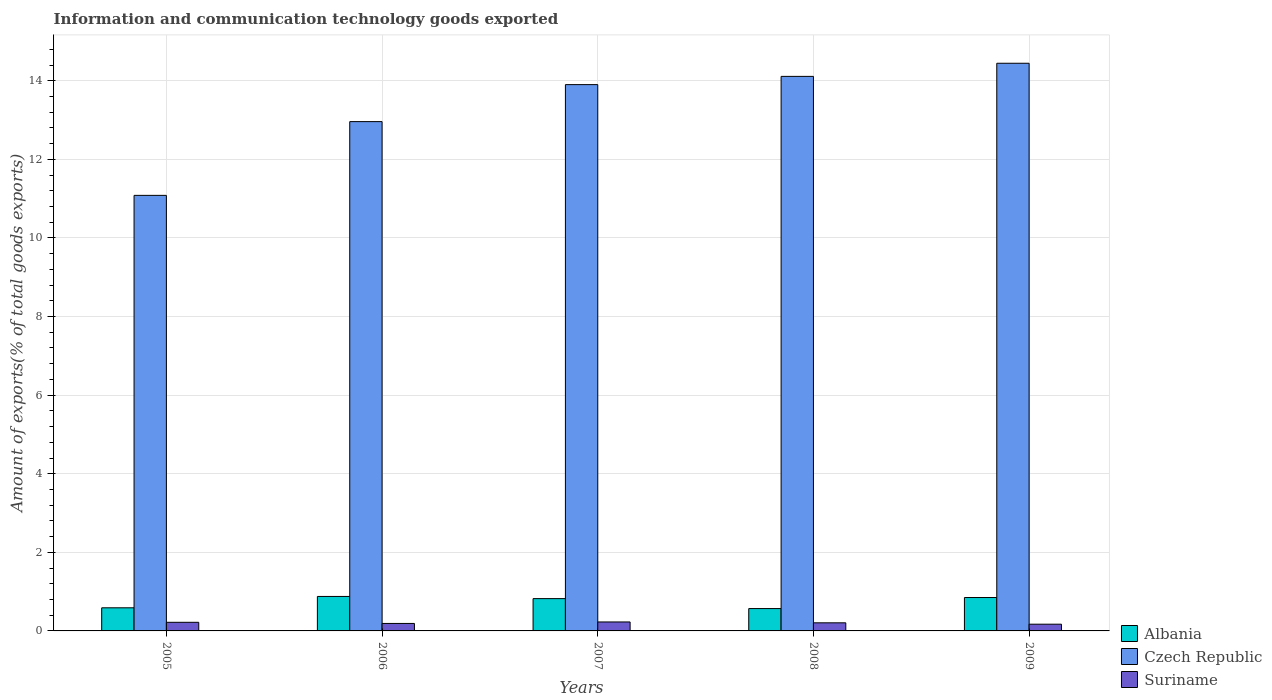How many groups of bars are there?
Your response must be concise. 5. Are the number of bars per tick equal to the number of legend labels?
Give a very brief answer. Yes. How many bars are there on the 5th tick from the left?
Give a very brief answer. 3. In how many cases, is the number of bars for a given year not equal to the number of legend labels?
Your response must be concise. 0. What is the amount of goods exported in Czech Republic in 2006?
Give a very brief answer. 12.96. Across all years, what is the maximum amount of goods exported in Albania?
Offer a very short reply. 0.88. Across all years, what is the minimum amount of goods exported in Albania?
Offer a very short reply. 0.57. In which year was the amount of goods exported in Suriname maximum?
Offer a terse response. 2007. In which year was the amount of goods exported in Czech Republic minimum?
Offer a terse response. 2005. What is the total amount of goods exported in Suriname in the graph?
Ensure brevity in your answer.  1.01. What is the difference between the amount of goods exported in Suriname in 2006 and that in 2008?
Keep it short and to the point. -0.02. What is the difference between the amount of goods exported in Suriname in 2009 and the amount of goods exported in Czech Republic in 2006?
Your answer should be very brief. -12.79. What is the average amount of goods exported in Albania per year?
Your answer should be very brief. 0.74. In the year 2007, what is the difference between the amount of goods exported in Albania and amount of goods exported in Suriname?
Offer a very short reply. 0.59. In how many years, is the amount of goods exported in Albania greater than 12.8 %?
Your answer should be very brief. 0. What is the ratio of the amount of goods exported in Suriname in 2007 to that in 2009?
Give a very brief answer. 1.33. What is the difference between the highest and the second highest amount of goods exported in Czech Republic?
Offer a terse response. 0.33. What is the difference between the highest and the lowest amount of goods exported in Albania?
Offer a terse response. 0.31. In how many years, is the amount of goods exported in Czech Republic greater than the average amount of goods exported in Czech Republic taken over all years?
Your answer should be compact. 3. Is the sum of the amount of goods exported in Czech Republic in 2006 and 2009 greater than the maximum amount of goods exported in Albania across all years?
Ensure brevity in your answer.  Yes. What does the 2nd bar from the left in 2007 represents?
Your response must be concise. Czech Republic. What does the 1st bar from the right in 2006 represents?
Make the answer very short. Suriname. Are all the bars in the graph horizontal?
Your answer should be compact. No. Does the graph contain any zero values?
Provide a succinct answer. No. Does the graph contain grids?
Your answer should be compact. Yes. Where does the legend appear in the graph?
Offer a terse response. Bottom right. How many legend labels are there?
Ensure brevity in your answer.  3. What is the title of the graph?
Provide a succinct answer. Information and communication technology goods exported. Does "Chad" appear as one of the legend labels in the graph?
Your response must be concise. No. What is the label or title of the X-axis?
Offer a very short reply. Years. What is the label or title of the Y-axis?
Provide a short and direct response. Amount of exports(% of total goods exports). What is the Amount of exports(% of total goods exports) of Albania in 2005?
Your answer should be very brief. 0.59. What is the Amount of exports(% of total goods exports) of Czech Republic in 2005?
Your response must be concise. 11.08. What is the Amount of exports(% of total goods exports) of Suriname in 2005?
Your answer should be compact. 0.22. What is the Amount of exports(% of total goods exports) of Albania in 2006?
Your answer should be very brief. 0.88. What is the Amount of exports(% of total goods exports) of Czech Republic in 2006?
Your answer should be compact. 12.96. What is the Amount of exports(% of total goods exports) of Suriname in 2006?
Provide a short and direct response. 0.19. What is the Amount of exports(% of total goods exports) in Albania in 2007?
Your response must be concise. 0.82. What is the Amount of exports(% of total goods exports) of Czech Republic in 2007?
Your answer should be compact. 13.9. What is the Amount of exports(% of total goods exports) in Suriname in 2007?
Provide a succinct answer. 0.23. What is the Amount of exports(% of total goods exports) in Albania in 2008?
Your answer should be very brief. 0.57. What is the Amount of exports(% of total goods exports) in Czech Republic in 2008?
Provide a succinct answer. 14.11. What is the Amount of exports(% of total goods exports) in Suriname in 2008?
Make the answer very short. 0.21. What is the Amount of exports(% of total goods exports) in Albania in 2009?
Your response must be concise. 0.85. What is the Amount of exports(% of total goods exports) in Czech Republic in 2009?
Your answer should be very brief. 14.44. What is the Amount of exports(% of total goods exports) of Suriname in 2009?
Offer a very short reply. 0.17. Across all years, what is the maximum Amount of exports(% of total goods exports) in Albania?
Your response must be concise. 0.88. Across all years, what is the maximum Amount of exports(% of total goods exports) in Czech Republic?
Your response must be concise. 14.44. Across all years, what is the maximum Amount of exports(% of total goods exports) of Suriname?
Give a very brief answer. 0.23. Across all years, what is the minimum Amount of exports(% of total goods exports) in Albania?
Provide a succinct answer. 0.57. Across all years, what is the minimum Amount of exports(% of total goods exports) of Czech Republic?
Offer a terse response. 11.08. Across all years, what is the minimum Amount of exports(% of total goods exports) in Suriname?
Provide a succinct answer. 0.17. What is the total Amount of exports(% of total goods exports) in Albania in the graph?
Your answer should be very brief. 3.71. What is the total Amount of exports(% of total goods exports) of Czech Republic in the graph?
Offer a very short reply. 66.5. What is the total Amount of exports(% of total goods exports) of Suriname in the graph?
Give a very brief answer. 1.01. What is the difference between the Amount of exports(% of total goods exports) in Albania in 2005 and that in 2006?
Your answer should be very brief. -0.29. What is the difference between the Amount of exports(% of total goods exports) in Czech Republic in 2005 and that in 2006?
Provide a short and direct response. -1.88. What is the difference between the Amount of exports(% of total goods exports) in Suriname in 2005 and that in 2006?
Your response must be concise. 0.03. What is the difference between the Amount of exports(% of total goods exports) of Albania in 2005 and that in 2007?
Your answer should be compact. -0.23. What is the difference between the Amount of exports(% of total goods exports) in Czech Republic in 2005 and that in 2007?
Keep it short and to the point. -2.82. What is the difference between the Amount of exports(% of total goods exports) of Suriname in 2005 and that in 2007?
Offer a very short reply. -0.01. What is the difference between the Amount of exports(% of total goods exports) of Albania in 2005 and that in 2008?
Provide a short and direct response. 0.02. What is the difference between the Amount of exports(% of total goods exports) of Czech Republic in 2005 and that in 2008?
Make the answer very short. -3.03. What is the difference between the Amount of exports(% of total goods exports) of Suriname in 2005 and that in 2008?
Provide a succinct answer. 0.01. What is the difference between the Amount of exports(% of total goods exports) of Albania in 2005 and that in 2009?
Ensure brevity in your answer.  -0.26. What is the difference between the Amount of exports(% of total goods exports) in Czech Republic in 2005 and that in 2009?
Your answer should be compact. -3.36. What is the difference between the Amount of exports(% of total goods exports) in Suriname in 2005 and that in 2009?
Offer a terse response. 0.05. What is the difference between the Amount of exports(% of total goods exports) in Albania in 2006 and that in 2007?
Provide a short and direct response. 0.06. What is the difference between the Amount of exports(% of total goods exports) of Czech Republic in 2006 and that in 2007?
Your answer should be very brief. -0.94. What is the difference between the Amount of exports(% of total goods exports) in Suriname in 2006 and that in 2007?
Ensure brevity in your answer.  -0.04. What is the difference between the Amount of exports(% of total goods exports) in Albania in 2006 and that in 2008?
Your answer should be very brief. 0.31. What is the difference between the Amount of exports(% of total goods exports) of Czech Republic in 2006 and that in 2008?
Make the answer very short. -1.15. What is the difference between the Amount of exports(% of total goods exports) of Suriname in 2006 and that in 2008?
Keep it short and to the point. -0.02. What is the difference between the Amount of exports(% of total goods exports) of Albania in 2006 and that in 2009?
Provide a succinct answer. 0.03. What is the difference between the Amount of exports(% of total goods exports) of Czech Republic in 2006 and that in 2009?
Your answer should be very brief. -1.48. What is the difference between the Amount of exports(% of total goods exports) in Suriname in 2006 and that in 2009?
Provide a succinct answer. 0.02. What is the difference between the Amount of exports(% of total goods exports) in Albania in 2007 and that in 2008?
Provide a succinct answer. 0.25. What is the difference between the Amount of exports(% of total goods exports) in Czech Republic in 2007 and that in 2008?
Provide a succinct answer. -0.21. What is the difference between the Amount of exports(% of total goods exports) of Suriname in 2007 and that in 2008?
Keep it short and to the point. 0.02. What is the difference between the Amount of exports(% of total goods exports) of Albania in 2007 and that in 2009?
Your answer should be compact. -0.03. What is the difference between the Amount of exports(% of total goods exports) of Czech Republic in 2007 and that in 2009?
Provide a succinct answer. -0.54. What is the difference between the Amount of exports(% of total goods exports) in Suriname in 2007 and that in 2009?
Make the answer very short. 0.06. What is the difference between the Amount of exports(% of total goods exports) in Albania in 2008 and that in 2009?
Keep it short and to the point. -0.28. What is the difference between the Amount of exports(% of total goods exports) of Czech Republic in 2008 and that in 2009?
Your response must be concise. -0.33. What is the difference between the Amount of exports(% of total goods exports) of Suriname in 2008 and that in 2009?
Provide a succinct answer. 0.04. What is the difference between the Amount of exports(% of total goods exports) in Albania in 2005 and the Amount of exports(% of total goods exports) in Czech Republic in 2006?
Your answer should be compact. -12.37. What is the difference between the Amount of exports(% of total goods exports) in Albania in 2005 and the Amount of exports(% of total goods exports) in Suriname in 2006?
Make the answer very short. 0.4. What is the difference between the Amount of exports(% of total goods exports) of Czech Republic in 2005 and the Amount of exports(% of total goods exports) of Suriname in 2006?
Your response must be concise. 10.89. What is the difference between the Amount of exports(% of total goods exports) of Albania in 2005 and the Amount of exports(% of total goods exports) of Czech Republic in 2007?
Provide a short and direct response. -13.31. What is the difference between the Amount of exports(% of total goods exports) in Albania in 2005 and the Amount of exports(% of total goods exports) in Suriname in 2007?
Give a very brief answer. 0.36. What is the difference between the Amount of exports(% of total goods exports) of Czech Republic in 2005 and the Amount of exports(% of total goods exports) of Suriname in 2007?
Provide a succinct answer. 10.85. What is the difference between the Amount of exports(% of total goods exports) of Albania in 2005 and the Amount of exports(% of total goods exports) of Czech Republic in 2008?
Your response must be concise. -13.52. What is the difference between the Amount of exports(% of total goods exports) of Albania in 2005 and the Amount of exports(% of total goods exports) of Suriname in 2008?
Keep it short and to the point. 0.38. What is the difference between the Amount of exports(% of total goods exports) in Czech Republic in 2005 and the Amount of exports(% of total goods exports) in Suriname in 2008?
Offer a terse response. 10.88. What is the difference between the Amount of exports(% of total goods exports) of Albania in 2005 and the Amount of exports(% of total goods exports) of Czech Republic in 2009?
Keep it short and to the point. -13.86. What is the difference between the Amount of exports(% of total goods exports) in Albania in 2005 and the Amount of exports(% of total goods exports) in Suriname in 2009?
Offer a terse response. 0.42. What is the difference between the Amount of exports(% of total goods exports) of Czech Republic in 2005 and the Amount of exports(% of total goods exports) of Suriname in 2009?
Offer a terse response. 10.91. What is the difference between the Amount of exports(% of total goods exports) of Albania in 2006 and the Amount of exports(% of total goods exports) of Czech Republic in 2007?
Your answer should be compact. -13.02. What is the difference between the Amount of exports(% of total goods exports) in Albania in 2006 and the Amount of exports(% of total goods exports) in Suriname in 2007?
Provide a succinct answer. 0.65. What is the difference between the Amount of exports(% of total goods exports) of Czech Republic in 2006 and the Amount of exports(% of total goods exports) of Suriname in 2007?
Offer a very short reply. 12.73. What is the difference between the Amount of exports(% of total goods exports) of Albania in 2006 and the Amount of exports(% of total goods exports) of Czech Republic in 2008?
Your answer should be very brief. -13.23. What is the difference between the Amount of exports(% of total goods exports) of Albania in 2006 and the Amount of exports(% of total goods exports) of Suriname in 2008?
Offer a terse response. 0.67. What is the difference between the Amount of exports(% of total goods exports) in Czech Republic in 2006 and the Amount of exports(% of total goods exports) in Suriname in 2008?
Provide a short and direct response. 12.75. What is the difference between the Amount of exports(% of total goods exports) of Albania in 2006 and the Amount of exports(% of total goods exports) of Czech Republic in 2009?
Offer a very short reply. -13.57. What is the difference between the Amount of exports(% of total goods exports) of Albania in 2006 and the Amount of exports(% of total goods exports) of Suriname in 2009?
Provide a succinct answer. 0.71. What is the difference between the Amount of exports(% of total goods exports) in Czech Republic in 2006 and the Amount of exports(% of total goods exports) in Suriname in 2009?
Provide a succinct answer. 12.79. What is the difference between the Amount of exports(% of total goods exports) in Albania in 2007 and the Amount of exports(% of total goods exports) in Czech Republic in 2008?
Your answer should be very brief. -13.29. What is the difference between the Amount of exports(% of total goods exports) in Albania in 2007 and the Amount of exports(% of total goods exports) in Suriname in 2008?
Keep it short and to the point. 0.62. What is the difference between the Amount of exports(% of total goods exports) of Czech Republic in 2007 and the Amount of exports(% of total goods exports) of Suriname in 2008?
Provide a short and direct response. 13.69. What is the difference between the Amount of exports(% of total goods exports) of Albania in 2007 and the Amount of exports(% of total goods exports) of Czech Republic in 2009?
Offer a terse response. -13.62. What is the difference between the Amount of exports(% of total goods exports) of Albania in 2007 and the Amount of exports(% of total goods exports) of Suriname in 2009?
Provide a succinct answer. 0.65. What is the difference between the Amount of exports(% of total goods exports) of Czech Republic in 2007 and the Amount of exports(% of total goods exports) of Suriname in 2009?
Provide a short and direct response. 13.73. What is the difference between the Amount of exports(% of total goods exports) of Albania in 2008 and the Amount of exports(% of total goods exports) of Czech Republic in 2009?
Keep it short and to the point. -13.88. What is the difference between the Amount of exports(% of total goods exports) of Albania in 2008 and the Amount of exports(% of total goods exports) of Suriname in 2009?
Your answer should be compact. 0.4. What is the difference between the Amount of exports(% of total goods exports) of Czech Republic in 2008 and the Amount of exports(% of total goods exports) of Suriname in 2009?
Your answer should be very brief. 13.94. What is the average Amount of exports(% of total goods exports) of Albania per year?
Your answer should be very brief. 0.74. What is the average Amount of exports(% of total goods exports) in Czech Republic per year?
Provide a succinct answer. 13.3. What is the average Amount of exports(% of total goods exports) of Suriname per year?
Offer a very short reply. 0.2. In the year 2005, what is the difference between the Amount of exports(% of total goods exports) of Albania and Amount of exports(% of total goods exports) of Czech Republic?
Offer a very short reply. -10.49. In the year 2005, what is the difference between the Amount of exports(% of total goods exports) in Albania and Amount of exports(% of total goods exports) in Suriname?
Keep it short and to the point. 0.37. In the year 2005, what is the difference between the Amount of exports(% of total goods exports) of Czech Republic and Amount of exports(% of total goods exports) of Suriname?
Give a very brief answer. 10.86. In the year 2006, what is the difference between the Amount of exports(% of total goods exports) in Albania and Amount of exports(% of total goods exports) in Czech Republic?
Ensure brevity in your answer.  -12.08. In the year 2006, what is the difference between the Amount of exports(% of total goods exports) in Albania and Amount of exports(% of total goods exports) in Suriname?
Offer a very short reply. 0.69. In the year 2006, what is the difference between the Amount of exports(% of total goods exports) in Czech Republic and Amount of exports(% of total goods exports) in Suriname?
Offer a very short reply. 12.77. In the year 2007, what is the difference between the Amount of exports(% of total goods exports) in Albania and Amount of exports(% of total goods exports) in Czech Republic?
Your answer should be compact. -13.08. In the year 2007, what is the difference between the Amount of exports(% of total goods exports) in Albania and Amount of exports(% of total goods exports) in Suriname?
Offer a terse response. 0.59. In the year 2007, what is the difference between the Amount of exports(% of total goods exports) of Czech Republic and Amount of exports(% of total goods exports) of Suriname?
Provide a succinct answer. 13.67. In the year 2008, what is the difference between the Amount of exports(% of total goods exports) in Albania and Amount of exports(% of total goods exports) in Czech Republic?
Your response must be concise. -13.54. In the year 2008, what is the difference between the Amount of exports(% of total goods exports) of Albania and Amount of exports(% of total goods exports) of Suriname?
Your answer should be very brief. 0.36. In the year 2008, what is the difference between the Amount of exports(% of total goods exports) in Czech Republic and Amount of exports(% of total goods exports) in Suriname?
Provide a succinct answer. 13.9. In the year 2009, what is the difference between the Amount of exports(% of total goods exports) in Albania and Amount of exports(% of total goods exports) in Czech Republic?
Your answer should be compact. -13.59. In the year 2009, what is the difference between the Amount of exports(% of total goods exports) of Albania and Amount of exports(% of total goods exports) of Suriname?
Your answer should be very brief. 0.68. In the year 2009, what is the difference between the Amount of exports(% of total goods exports) in Czech Republic and Amount of exports(% of total goods exports) in Suriname?
Your response must be concise. 14.27. What is the ratio of the Amount of exports(% of total goods exports) of Albania in 2005 to that in 2006?
Ensure brevity in your answer.  0.67. What is the ratio of the Amount of exports(% of total goods exports) in Czech Republic in 2005 to that in 2006?
Make the answer very short. 0.86. What is the ratio of the Amount of exports(% of total goods exports) of Suriname in 2005 to that in 2006?
Provide a short and direct response. 1.15. What is the ratio of the Amount of exports(% of total goods exports) in Albania in 2005 to that in 2007?
Provide a short and direct response. 0.72. What is the ratio of the Amount of exports(% of total goods exports) in Czech Republic in 2005 to that in 2007?
Your answer should be compact. 0.8. What is the ratio of the Amount of exports(% of total goods exports) in Suriname in 2005 to that in 2007?
Provide a succinct answer. 0.96. What is the ratio of the Amount of exports(% of total goods exports) in Albania in 2005 to that in 2008?
Offer a terse response. 1.03. What is the ratio of the Amount of exports(% of total goods exports) of Czech Republic in 2005 to that in 2008?
Give a very brief answer. 0.79. What is the ratio of the Amount of exports(% of total goods exports) in Suriname in 2005 to that in 2008?
Your answer should be very brief. 1.06. What is the ratio of the Amount of exports(% of total goods exports) of Albania in 2005 to that in 2009?
Ensure brevity in your answer.  0.69. What is the ratio of the Amount of exports(% of total goods exports) of Czech Republic in 2005 to that in 2009?
Give a very brief answer. 0.77. What is the ratio of the Amount of exports(% of total goods exports) in Suriname in 2005 to that in 2009?
Offer a very short reply. 1.28. What is the ratio of the Amount of exports(% of total goods exports) of Albania in 2006 to that in 2007?
Keep it short and to the point. 1.07. What is the ratio of the Amount of exports(% of total goods exports) of Czech Republic in 2006 to that in 2007?
Give a very brief answer. 0.93. What is the ratio of the Amount of exports(% of total goods exports) of Suriname in 2006 to that in 2007?
Make the answer very short. 0.83. What is the ratio of the Amount of exports(% of total goods exports) in Albania in 2006 to that in 2008?
Offer a very short reply. 1.54. What is the ratio of the Amount of exports(% of total goods exports) in Czech Republic in 2006 to that in 2008?
Your response must be concise. 0.92. What is the ratio of the Amount of exports(% of total goods exports) in Suriname in 2006 to that in 2008?
Keep it short and to the point. 0.92. What is the ratio of the Amount of exports(% of total goods exports) of Albania in 2006 to that in 2009?
Keep it short and to the point. 1.03. What is the ratio of the Amount of exports(% of total goods exports) in Czech Republic in 2006 to that in 2009?
Your answer should be compact. 0.9. What is the ratio of the Amount of exports(% of total goods exports) of Suriname in 2006 to that in 2009?
Provide a succinct answer. 1.11. What is the ratio of the Amount of exports(% of total goods exports) of Albania in 2007 to that in 2008?
Your answer should be compact. 1.45. What is the ratio of the Amount of exports(% of total goods exports) in Czech Republic in 2007 to that in 2008?
Keep it short and to the point. 0.99. What is the ratio of the Amount of exports(% of total goods exports) in Suriname in 2007 to that in 2008?
Make the answer very short. 1.11. What is the ratio of the Amount of exports(% of total goods exports) in Albania in 2007 to that in 2009?
Ensure brevity in your answer.  0.97. What is the ratio of the Amount of exports(% of total goods exports) of Czech Republic in 2007 to that in 2009?
Make the answer very short. 0.96. What is the ratio of the Amount of exports(% of total goods exports) in Suriname in 2007 to that in 2009?
Offer a very short reply. 1.33. What is the ratio of the Amount of exports(% of total goods exports) in Albania in 2008 to that in 2009?
Offer a very short reply. 0.67. What is the ratio of the Amount of exports(% of total goods exports) of Czech Republic in 2008 to that in 2009?
Keep it short and to the point. 0.98. What is the ratio of the Amount of exports(% of total goods exports) of Suriname in 2008 to that in 2009?
Offer a terse response. 1.21. What is the difference between the highest and the second highest Amount of exports(% of total goods exports) in Albania?
Provide a succinct answer. 0.03. What is the difference between the highest and the second highest Amount of exports(% of total goods exports) in Czech Republic?
Provide a short and direct response. 0.33. What is the difference between the highest and the second highest Amount of exports(% of total goods exports) of Suriname?
Make the answer very short. 0.01. What is the difference between the highest and the lowest Amount of exports(% of total goods exports) in Albania?
Keep it short and to the point. 0.31. What is the difference between the highest and the lowest Amount of exports(% of total goods exports) in Czech Republic?
Keep it short and to the point. 3.36. What is the difference between the highest and the lowest Amount of exports(% of total goods exports) in Suriname?
Provide a succinct answer. 0.06. 